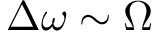<formula> <loc_0><loc_0><loc_500><loc_500>\Delta \omega \sim \Omega</formula> 